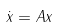Convert formula to latex. <formula><loc_0><loc_0><loc_500><loc_500>\dot { x } = A x</formula> 